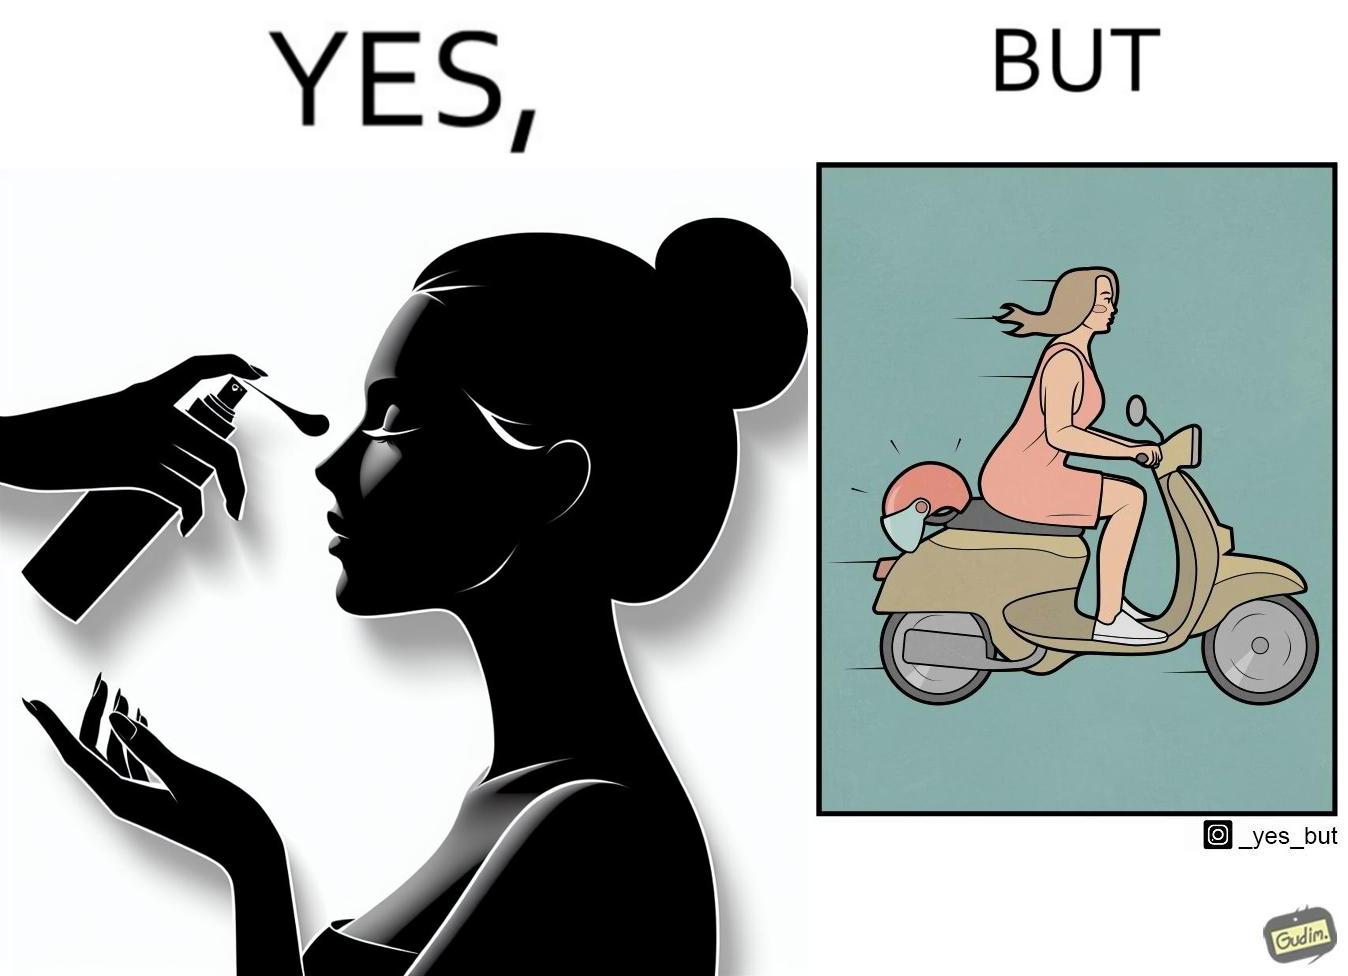Why is this image considered satirical? The image is funny because while the woman is concerned about protection from the sun rays, she is not concerned about her safety while riding a scooter. 